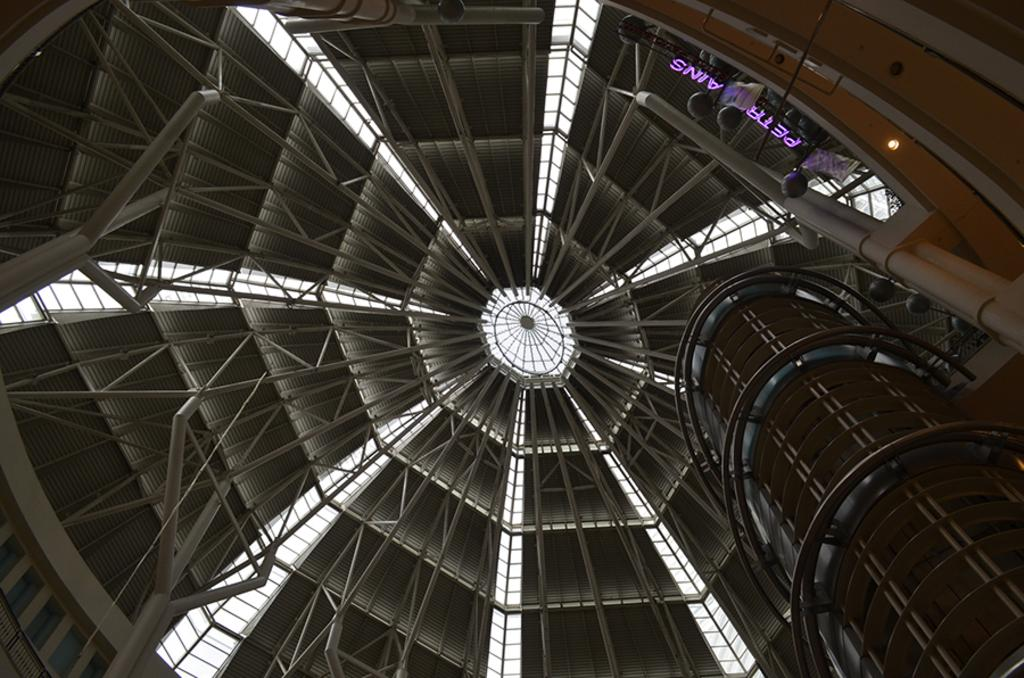What type of surface is visible in the image? There is a rooftop in the image. What type of material can be seen in the image? Metal rods are present in the image. What can be used for illumination in the image? Lights are visible in the image. What type of structure is shown in the image? There is a building in the image. What type of protest is taking place on the rooftop in the image? There is no protest present in the image; it only shows a rooftop, metal rods, lights, and a building. What type of copper is visible in the image? There is no copper present in the image. 